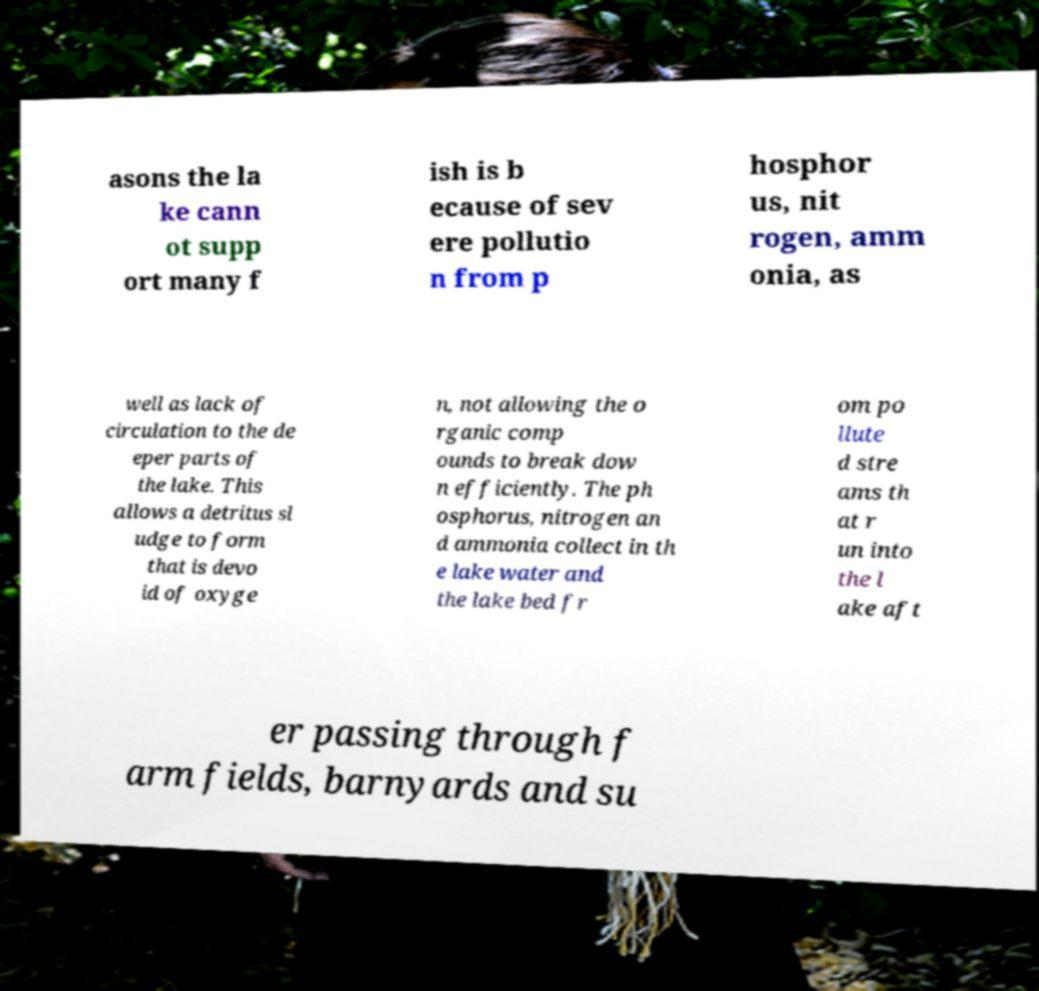There's text embedded in this image that I need extracted. Can you transcribe it verbatim? asons the la ke cann ot supp ort many f ish is b ecause of sev ere pollutio n from p hosphor us, nit rogen, amm onia, as well as lack of circulation to the de eper parts of the lake. This allows a detritus sl udge to form that is devo id of oxyge n, not allowing the o rganic comp ounds to break dow n efficiently. The ph osphorus, nitrogen an d ammonia collect in th e lake water and the lake bed fr om po llute d stre ams th at r un into the l ake aft er passing through f arm fields, barnyards and su 